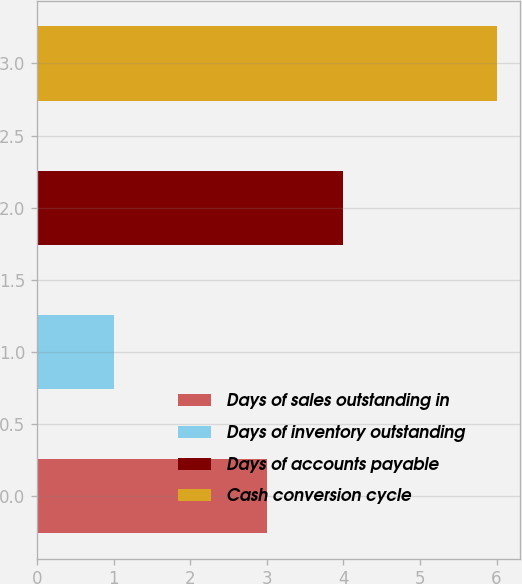Convert chart. <chart><loc_0><loc_0><loc_500><loc_500><bar_chart><fcel>Days of sales outstanding in<fcel>Days of inventory outstanding<fcel>Days of accounts payable<fcel>Cash conversion cycle<nl><fcel>3<fcel>1<fcel>4<fcel>6<nl></chart> 